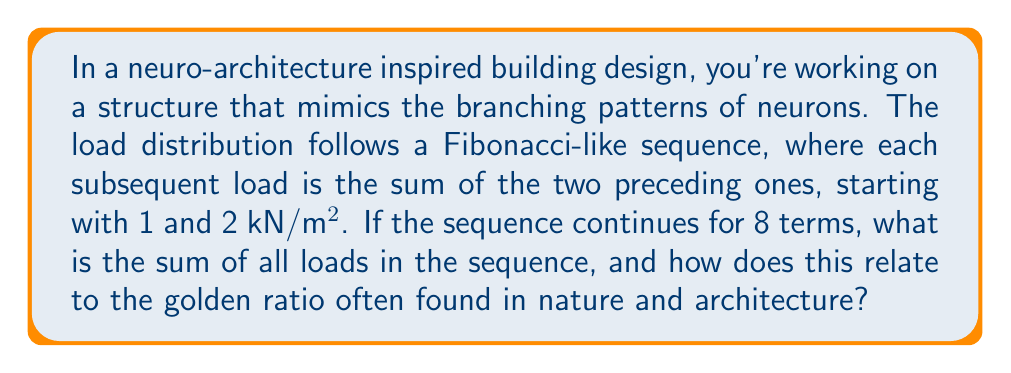Solve this math problem. Let's approach this step-by-step:

1) First, let's write out the Fibonacci-like sequence for 8 terms:
   $1, 2, 3, 5, 8, 13, 21, 34$

2) To find the sum, we add all these terms:
   $S = 1 + 2 + 3 + 5 + 8 + 13 + 21 + 34 = 87$ kN/m²

3) Now, let's explore how this relates to the golden ratio. The golden ratio, denoted by $\phi$, is approximately 1.618034...

4) In the Fibonacci sequence, as we progress further, the ratio of consecutive terms approaches the golden ratio. Let's calculate the ratios of the last few terms:

   $\frac{34}{21} \approx 1.619048$
   $\frac{21}{13} \approx 1.615385$
   $\frac{13}{8} = 1.625$

5) We can see these ratios are converging towards the golden ratio.

6) Interestingly, there's a formula that relates the sum of Fibonacci numbers to the golden ratio. For the nth Fibonacci number $F_n$, the sum of the first n Fibonacci numbers is given by:

   $$S_n = F_{n+2} - 1$$

7) In our case, the 8th term is 34, so the 10th term would be the sum. We can verify:
   $F_{10} = 89 - 1 = 88$, which is indeed our sum plus 1.

8) This relationship between the Fibonacci sequence, its sum, and the golden ratio is often found in nature and used in architecture for its aesthetic appeal and structural efficiency.
Answer: The sum of the 8-term load distribution sequence is 87 kN/m². This sequence demonstrates convergence towards the golden ratio (approximately 1.618) in the ratios of consecutive terms, reflecting natural growth patterns often utilized in neuro-architecture inspired designs. 